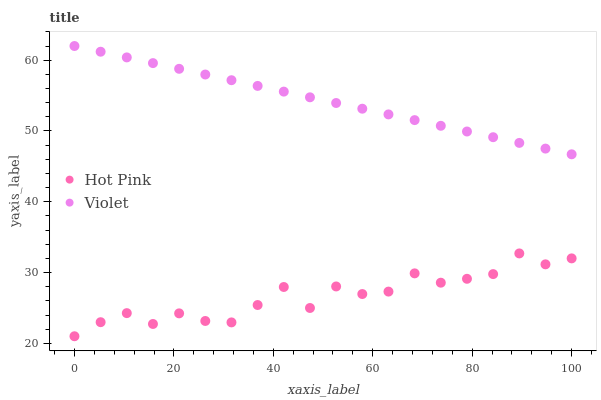Does Hot Pink have the minimum area under the curve?
Answer yes or no. Yes. Does Violet have the maximum area under the curve?
Answer yes or no. Yes. Does Violet have the minimum area under the curve?
Answer yes or no. No. Is Violet the smoothest?
Answer yes or no. Yes. Is Hot Pink the roughest?
Answer yes or no. Yes. Is Violet the roughest?
Answer yes or no. No. Does Hot Pink have the lowest value?
Answer yes or no. Yes. Does Violet have the lowest value?
Answer yes or no. No. Does Violet have the highest value?
Answer yes or no. Yes. Is Hot Pink less than Violet?
Answer yes or no. Yes. Is Violet greater than Hot Pink?
Answer yes or no. Yes. Does Hot Pink intersect Violet?
Answer yes or no. No. 